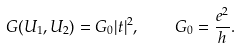Convert formula to latex. <formula><loc_0><loc_0><loc_500><loc_500>G ( U _ { 1 } , U _ { 2 } ) = G _ { 0 } | t | ^ { 2 } , \quad G _ { 0 } = \frac { e ^ { 2 } } { h } .</formula> 